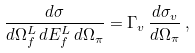<formula> <loc_0><loc_0><loc_500><loc_500>\frac { d \sigma } { d \Omega _ { f } ^ { L } \, d E _ { f } ^ { L } \, d \Omega _ { \pi } } = \Gamma _ { v } \, \frac { d \sigma _ { v } } { d \Omega _ { \pi } } \, ,</formula> 